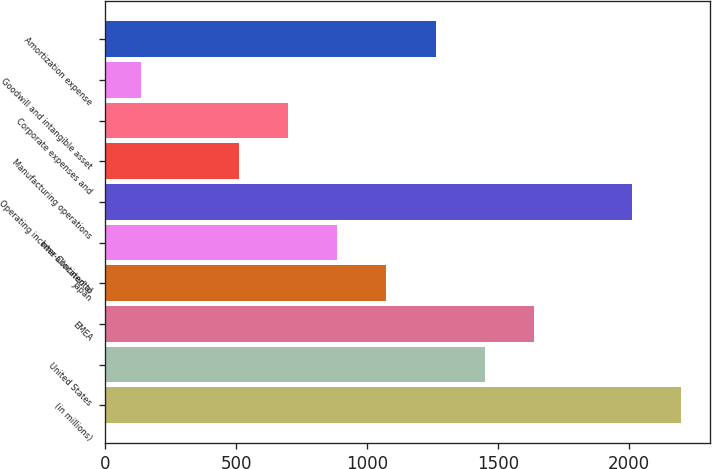Convert chart. <chart><loc_0><loc_0><loc_500><loc_500><bar_chart><fcel>(in millions)<fcel>United States<fcel>EMEA<fcel>Japan<fcel>Inter-Continental<fcel>Operating income allocated to<fcel>Manufacturing operations<fcel>Corporate expenses and<fcel>Goodwill and intangible asset<fcel>Amortization expense<nl><fcel>2198.6<fcel>1448.2<fcel>1635.8<fcel>1073<fcel>885.4<fcel>2011<fcel>510.2<fcel>697.8<fcel>135<fcel>1260.6<nl></chart> 